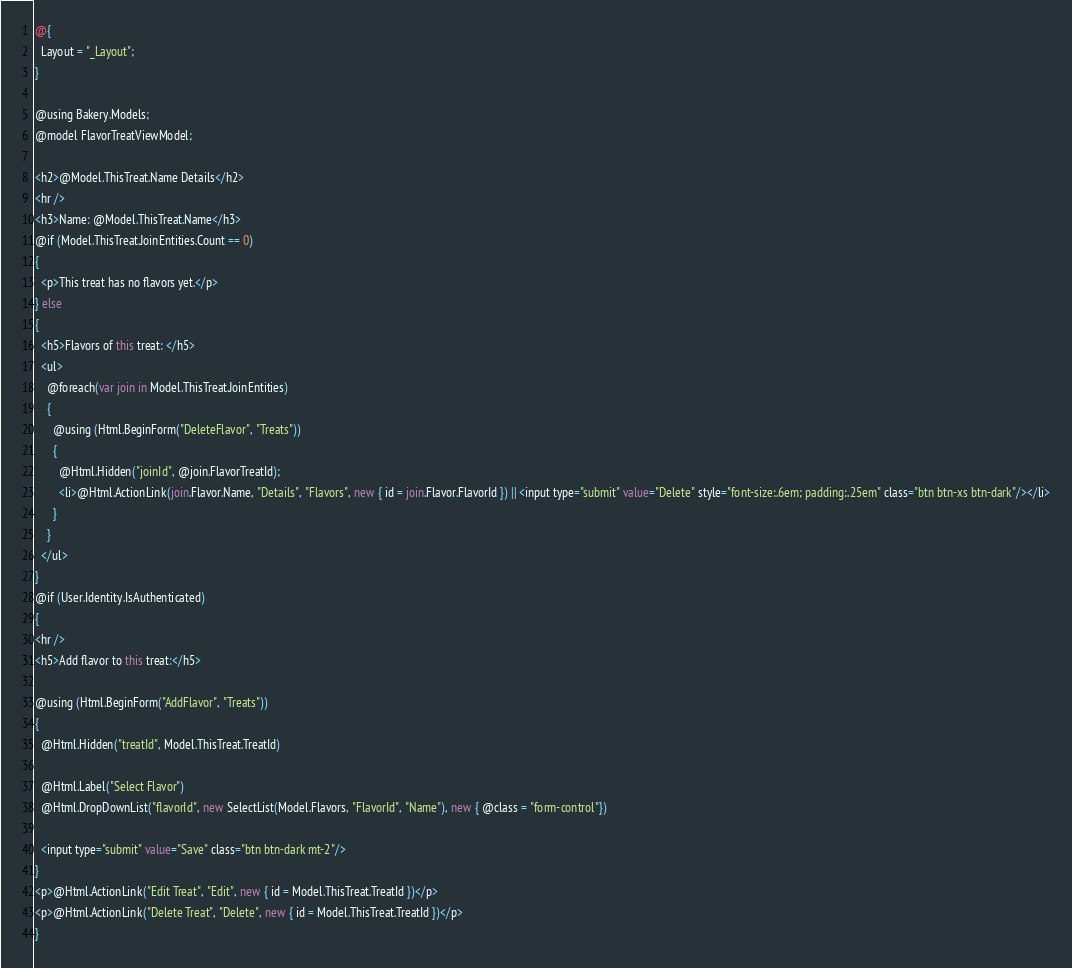Convert code to text. <code><loc_0><loc_0><loc_500><loc_500><_C#_>@{
  Layout = "_Layout";
}

@using Bakery.Models;
@model FlavorTreatViewModel;  

<h2>@Model.ThisTreat.Name Details</h2>
<hr />
<h3>Name: @Model.ThisTreat.Name</h3>
@if (Model.ThisTreat.JoinEntities.Count == 0)
{
  <p>This treat has no flavors yet.</p>
} else
{
  <h5>Flavors of this treat: </h5>
  <ul>
    @foreach(var join in Model.ThisTreat.JoinEntities)
    {
      @using (Html.BeginForm("DeleteFlavor", "Treats"))
      {  
        @Html.Hidden("joinId", @join.FlavorTreatId);
        <li>@Html.ActionLink(join.Flavor.Name, "Details", "Flavors", new { id = join.Flavor.FlavorId }) || <input type="submit" value="Delete" style="font-size:.6em; padding:.25em" class="btn btn-xs btn-dark"/></li>
      }
    }
  </ul> 
}
@if (User.Identity.IsAuthenticated)
{
<hr />
<h5>Add flavor to this treat:</h5>

@using (Html.BeginForm("AddFlavor", "Treats"))
{
  @Html.Hidden("treatId", Model.ThisTreat.TreatId)

  @Html.Label("Select Flavor")
  @Html.DropDownList("flavorId", new SelectList(Model.Flavors, "FlavorId", "Name"), new { @class = "form-control"})

  <input type="submit" value="Save" class="btn btn-dark mt-2"/>
}
<p>@Html.ActionLink("Edit Treat", "Edit", new { id = Model.ThisTreat.TreatId })</p>
<p>@Html.ActionLink("Delete Treat", "Delete", new { id = Model.ThisTreat.TreatId })</p>
}</code> 